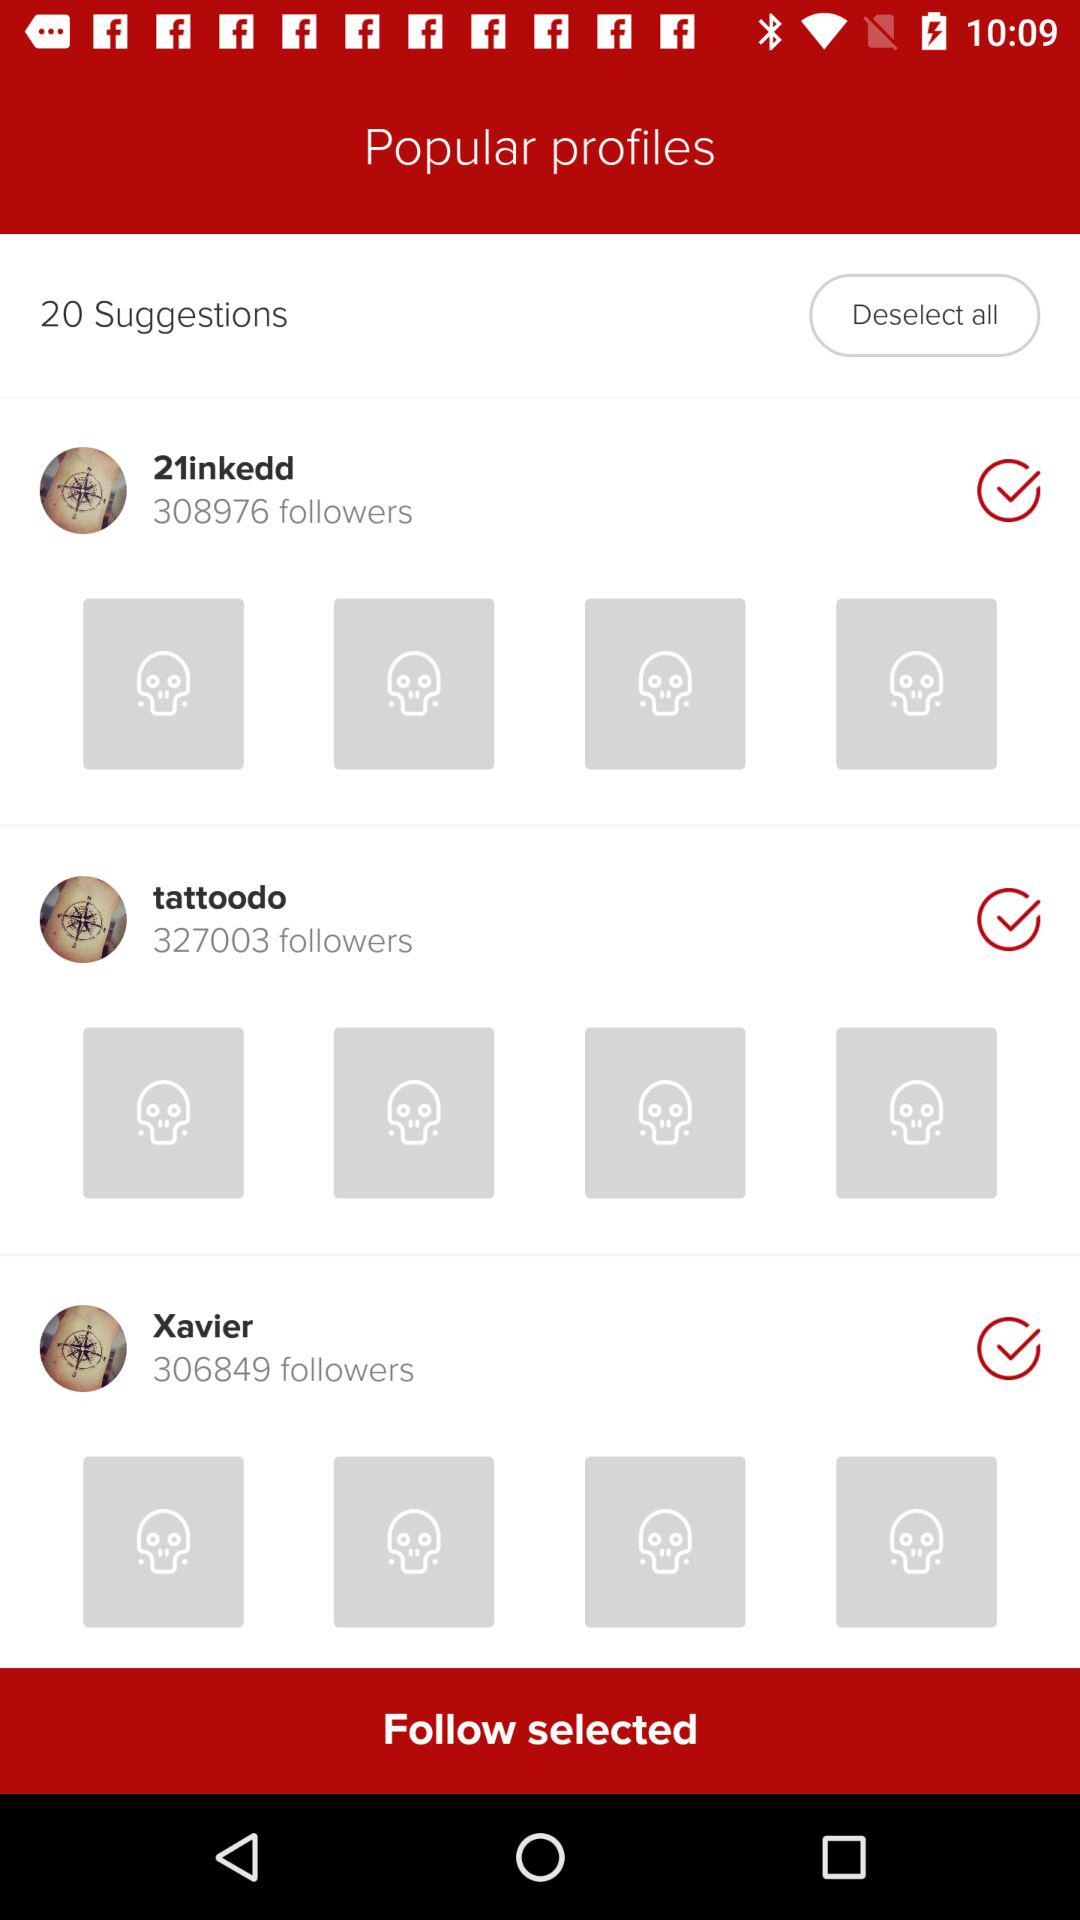How many followers does "tattoodo" have? "tattoodo" has 327003 followers. 